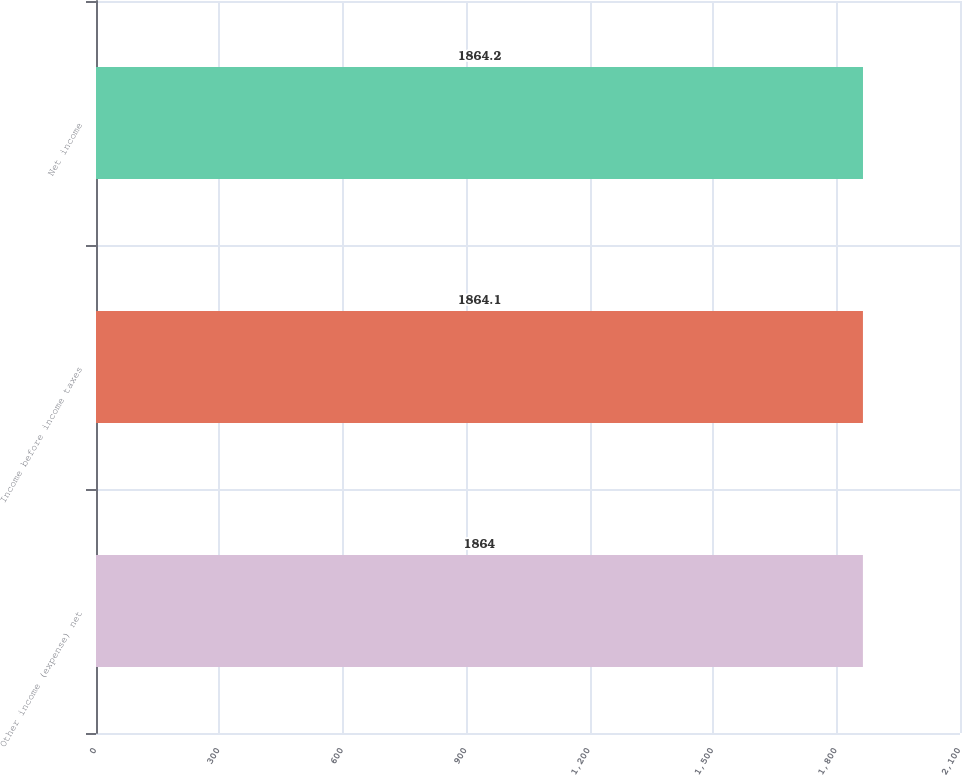<chart> <loc_0><loc_0><loc_500><loc_500><bar_chart><fcel>Other income (expense) net<fcel>Income before income taxes<fcel>Net income<nl><fcel>1864<fcel>1864.1<fcel>1864.2<nl></chart> 